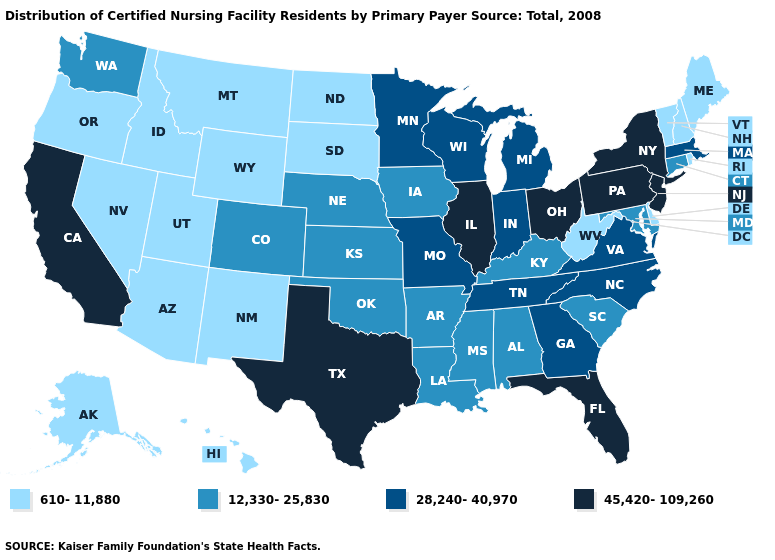What is the value of California?
Write a very short answer. 45,420-109,260. Does the first symbol in the legend represent the smallest category?
Concise answer only. Yes. What is the highest value in states that border Washington?
Concise answer only. 610-11,880. Name the states that have a value in the range 28,240-40,970?
Write a very short answer. Georgia, Indiana, Massachusetts, Michigan, Minnesota, Missouri, North Carolina, Tennessee, Virginia, Wisconsin. Among the states that border North Dakota , does Montana have the highest value?
Quick response, please. No. What is the value of Massachusetts?
Write a very short answer. 28,240-40,970. What is the value of North Dakota?
Give a very brief answer. 610-11,880. What is the value of New York?
Answer briefly. 45,420-109,260. What is the value of Connecticut?
Concise answer only. 12,330-25,830. What is the value of Iowa?
Write a very short answer. 12,330-25,830. Among the states that border Delaware , which have the highest value?
Concise answer only. New Jersey, Pennsylvania. What is the highest value in the USA?
Write a very short answer. 45,420-109,260. What is the value of New Mexico?
Write a very short answer. 610-11,880. 